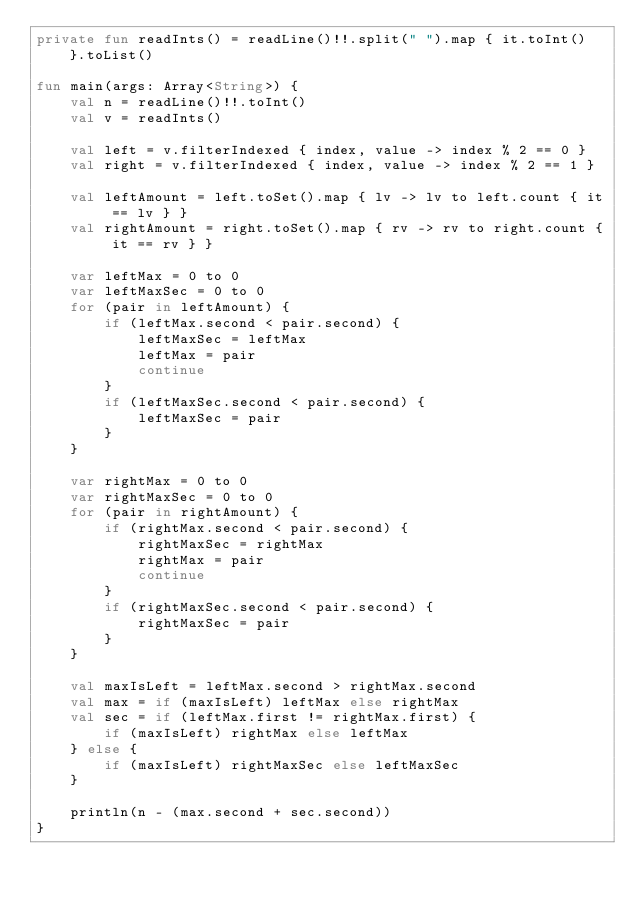Convert code to text. <code><loc_0><loc_0><loc_500><loc_500><_Kotlin_>private fun readInts() = readLine()!!.split(" ").map { it.toInt() }.toList()

fun main(args: Array<String>) {
    val n = readLine()!!.toInt()
    val v = readInts()

    val left = v.filterIndexed { index, value -> index % 2 == 0 }
    val right = v.filterIndexed { index, value -> index % 2 == 1 }

    val leftAmount = left.toSet().map { lv -> lv to left.count { it == lv } }
    val rightAmount = right.toSet().map { rv -> rv to right.count { it == rv } }

    var leftMax = 0 to 0
    var leftMaxSec = 0 to 0
    for (pair in leftAmount) {
        if (leftMax.second < pair.second) {
            leftMaxSec = leftMax
            leftMax = pair
            continue
        }
        if (leftMaxSec.second < pair.second) {
            leftMaxSec = pair
        }
    }

    var rightMax = 0 to 0
    var rightMaxSec = 0 to 0
    for (pair in rightAmount) {
        if (rightMax.second < pair.second) {
            rightMaxSec = rightMax
            rightMax = pair
            continue
        }
        if (rightMaxSec.second < pair.second) {
            rightMaxSec = pair
        }
    }

    val maxIsLeft = leftMax.second > rightMax.second
    val max = if (maxIsLeft) leftMax else rightMax
    val sec = if (leftMax.first != rightMax.first) {
        if (maxIsLeft) rightMax else leftMax
    } else {
        if (maxIsLeft) rightMaxSec else leftMaxSec
    }

    println(n - (max.second + sec.second))
}</code> 